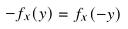Convert formula to latex. <formula><loc_0><loc_0><loc_500><loc_500>- f _ { x } ( y ) = f _ { x } ( - y )</formula> 